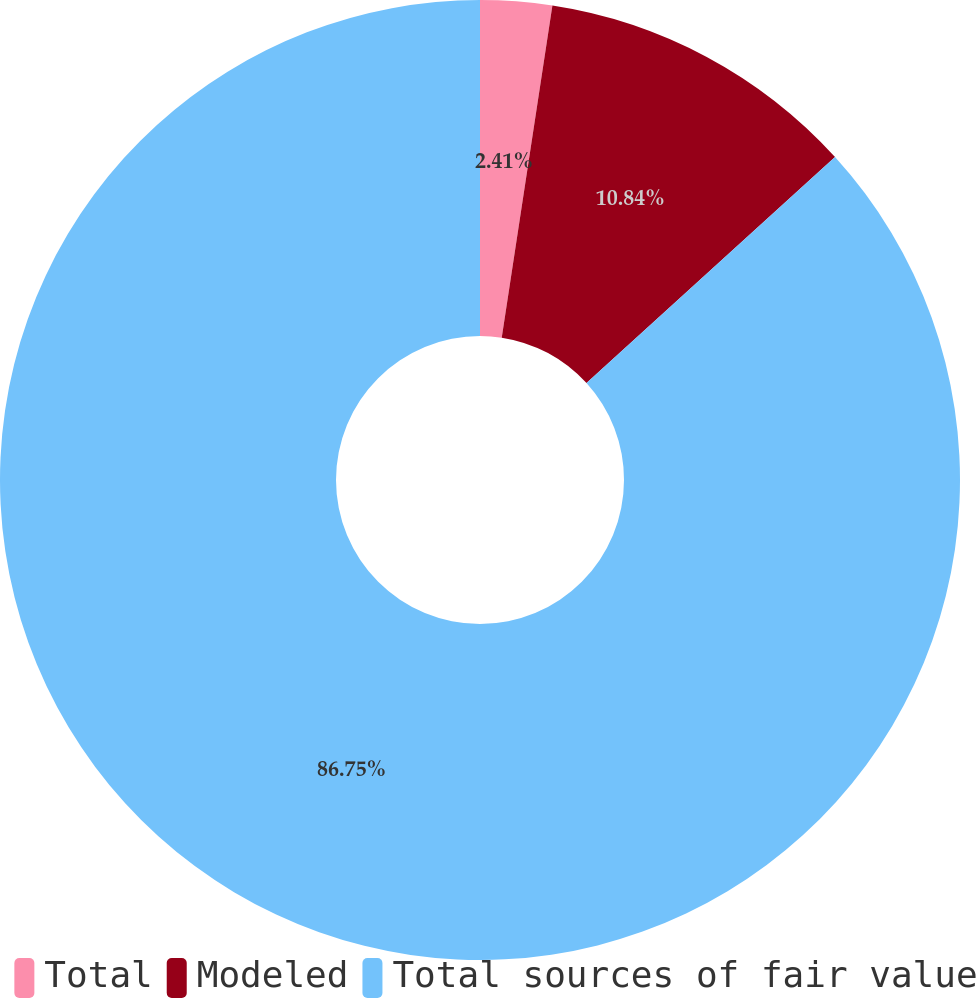Convert chart. <chart><loc_0><loc_0><loc_500><loc_500><pie_chart><fcel>Total<fcel>Modeled<fcel>Total sources of fair value<nl><fcel>2.41%<fcel>10.84%<fcel>86.75%<nl></chart> 